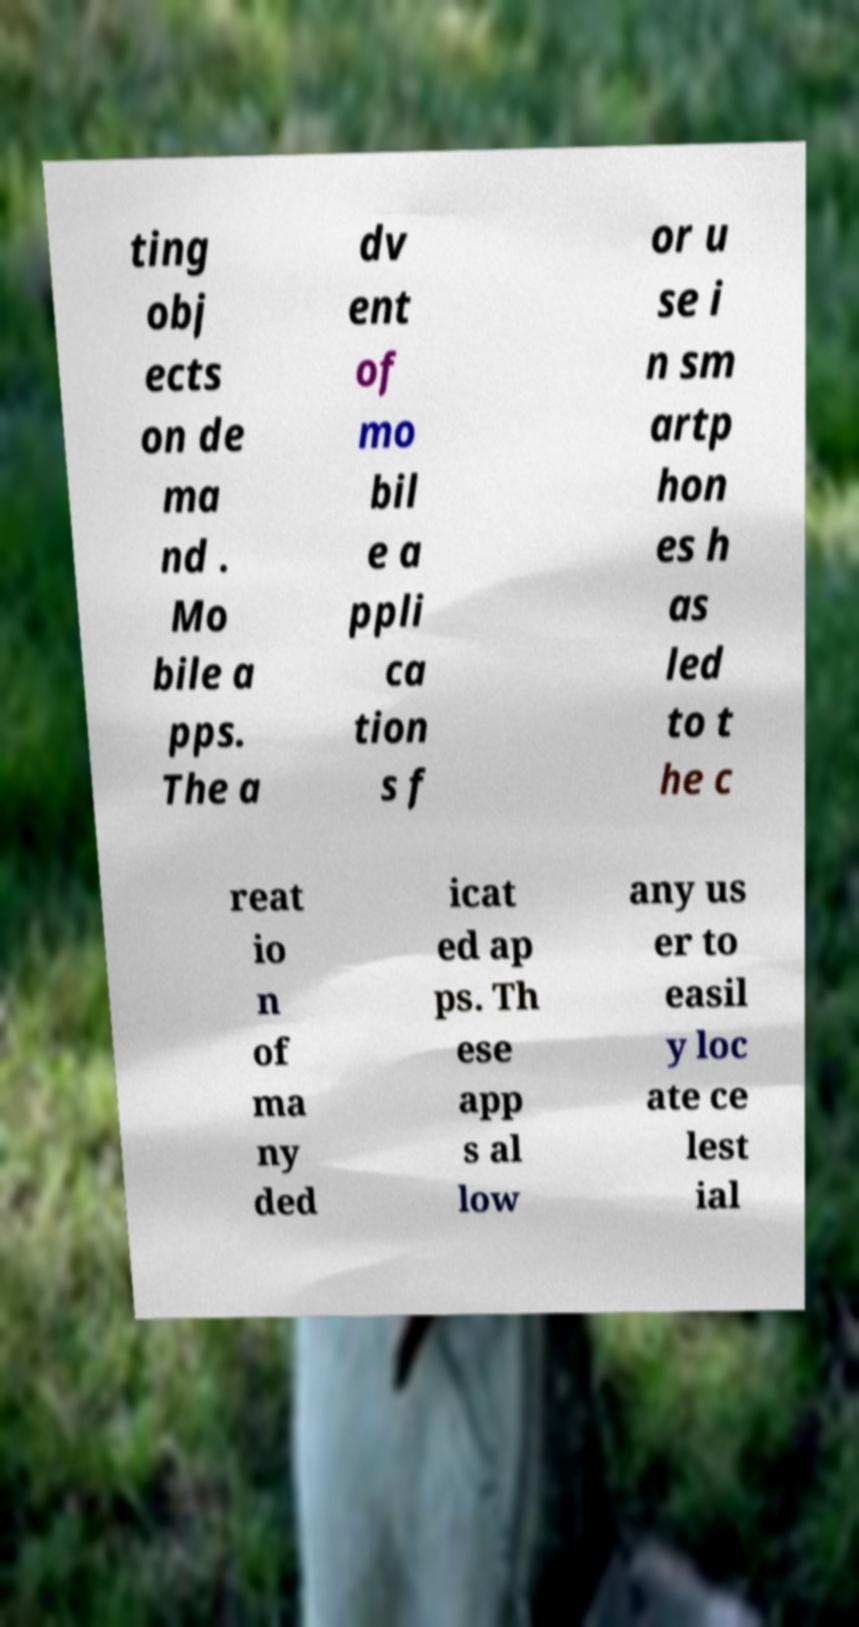Can you read and provide the text displayed in the image?This photo seems to have some interesting text. Can you extract and type it out for me? ting obj ects on de ma nd . Mo bile a pps. The a dv ent of mo bil e a ppli ca tion s f or u se i n sm artp hon es h as led to t he c reat io n of ma ny ded icat ed ap ps. Th ese app s al low any us er to easil y loc ate ce lest ial 